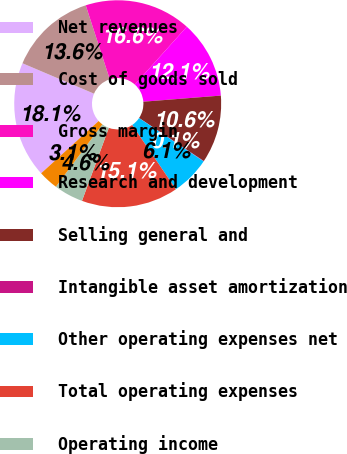Convert chart to OTSL. <chart><loc_0><loc_0><loc_500><loc_500><pie_chart><fcel>Net revenues<fcel>Cost of goods sold<fcel>Gross margin<fcel>Research and development<fcel>Selling general and<fcel>Intangible asset amortization<fcel>Other operating expenses net<fcel>Total operating expenses<fcel>Operating income<fcel>Interest (expense) income and<nl><fcel>18.13%<fcel>13.61%<fcel>16.63%<fcel>12.11%<fcel>10.6%<fcel>0.06%<fcel>6.08%<fcel>15.12%<fcel>4.58%<fcel>3.07%<nl></chart> 